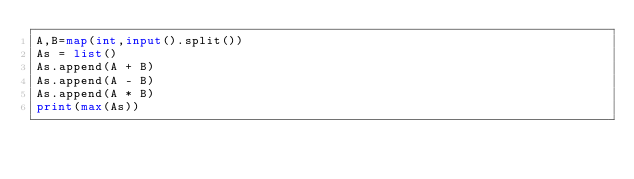<code> <loc_0><loc_0><loc_500><loc_500><_Python_>A,B=map(int,input().split())
As = list()
As.append(A + B)
As.append(A - B)
As.append(A * B)
print(max(As))</code> 